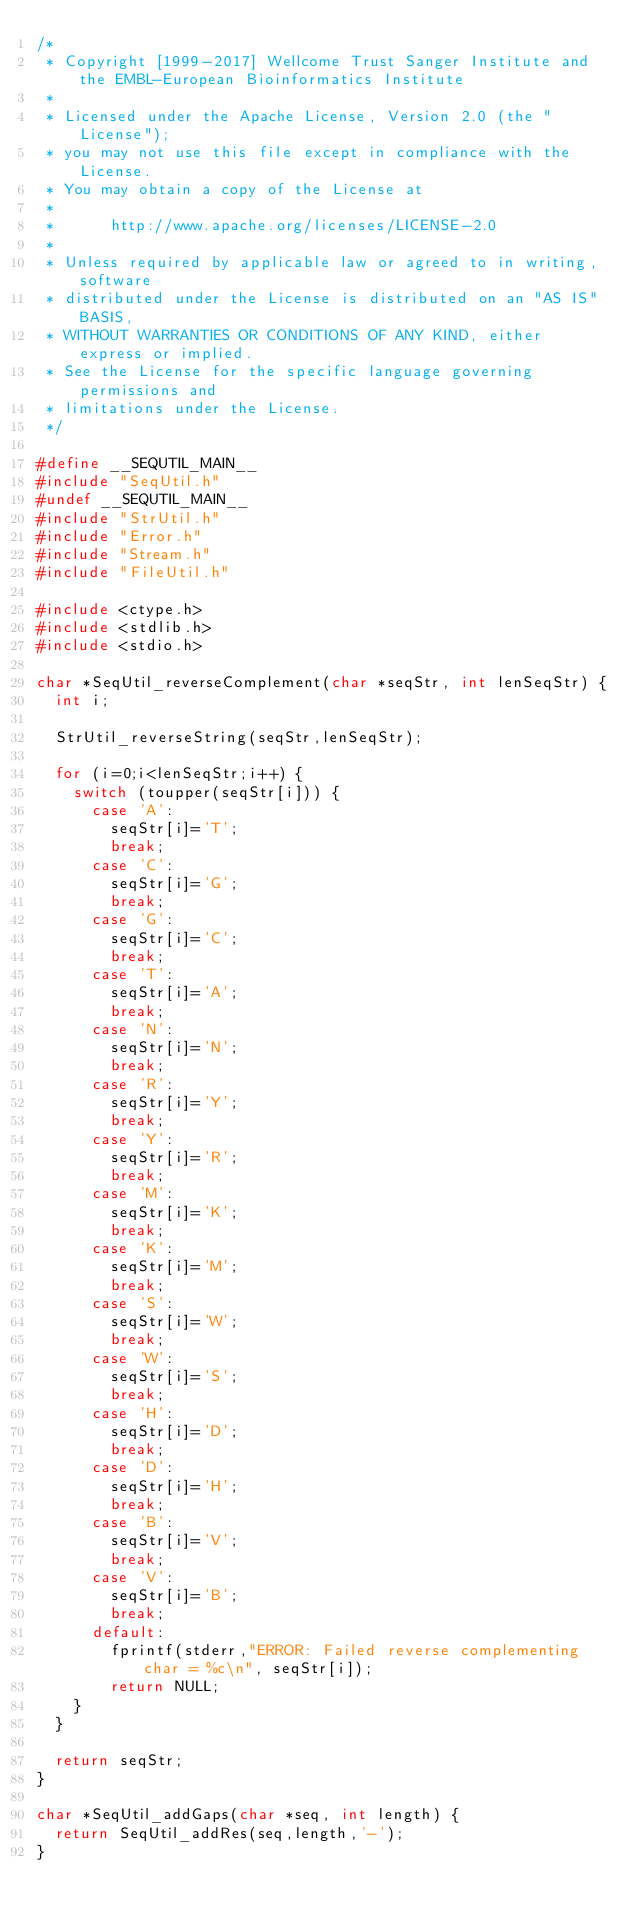<code> <loc_0><loc_0><loc_500><loc_500><_C_>/*
 * Copyright [1999-2017] Wellcome Trust Sanger Institute and the EMBL-European Bioinformatics Institute
 * 
 * Licensed under the Apache License, Version 2.0 (the "License");
 * you may not use this file except in compliance with the License.
 * You may obtain a copy of the License at
 * 
 *      http://www.apache.org/licenses/LICENSE-2.0
 * 
 * Unless required by applicable law or agreed to in writing, software
 * distributed under the License is distributed on an "AS IS" BASIS,
 * WITHOUT WARRANTIES OR CONDITIONS OF ANY KIND, either express or implied.
 * See the License for the specific language governing permissions and
 * limitations under the License.
 */

#define __SEQUTIL_MAIN__
#include "SeqUtil.h"
#undef __SEQUTIL_MAIN__
#include "StrUtil.h"
#include "Error.h"
#include "Stream.h"
#include "FileUtil.h"

#include <ctype.h>
#include <stdlib.h>
#include <stdio.h>

char *SeqUtil_reverseComplement(char *seqStr, int lenSeqStr) {
  int i;

  StrUtil_reverseString(seqStr,lenSeqStr);

  for (i=0;i<lenSeqStr;i++) {
    switch (toupper(seqStr[i])) {
      case 'A':
        seqStr[i]='T';
        break;
      case 'C':
        seqStr[i]='G';
        break;
      case 'G':
        seqStr[i]='C';
        break;
      case 'T':
        seqStr[i]='A';
        break;
      case 'N':
        seqStr[i]='N';
        break;
      case 'R':
        seqStr[i]='Y';
        break;
      case 'Y':
        seqStr[i]='R';
        break;
      case 'M':
        seqStr[i]='K';
        break;
      case 'K':
        seqStr[i]='M';
        break;
      case 'S':
        seqStr[i]='W';
        break;
      case 'W':
        seqStr[i]='S';
        break;
      case 'H':
        seqStr[i]='D';
        break;
      case 'D':
        seqStr[i]='H';
        break;
      case 'B':
        seqStr[i]='V';
        break;
      case 'V':
        seqStr[i]='B';
        break;
      default:
        fprintf(stderr,"ERROR: Failed reverse complementing char = %c\n", seqStr[i]);
        return NULL;
    }
  }
  
  return seqStr;
}

char *SeqUtil_addGaps(char *seq, int length) {
  return SeqUtil_addRes(seq,length,'-');
}
</code> 